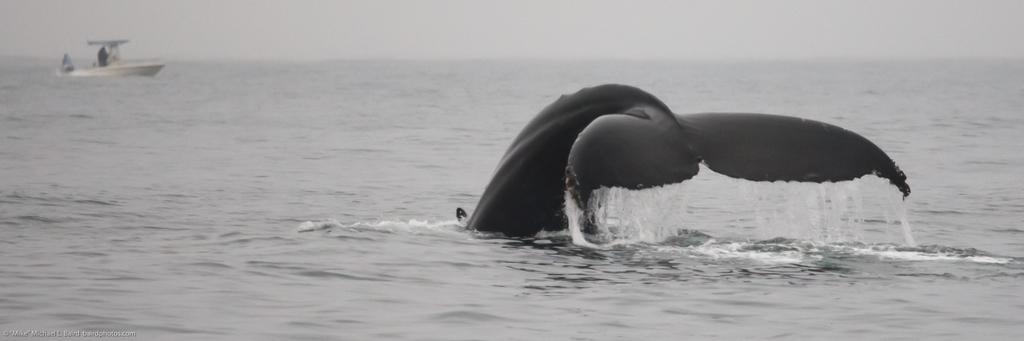Describe this image in one or two sentences. It is the black and white image in which there is a whale going into the water. In the background there is a boat. 